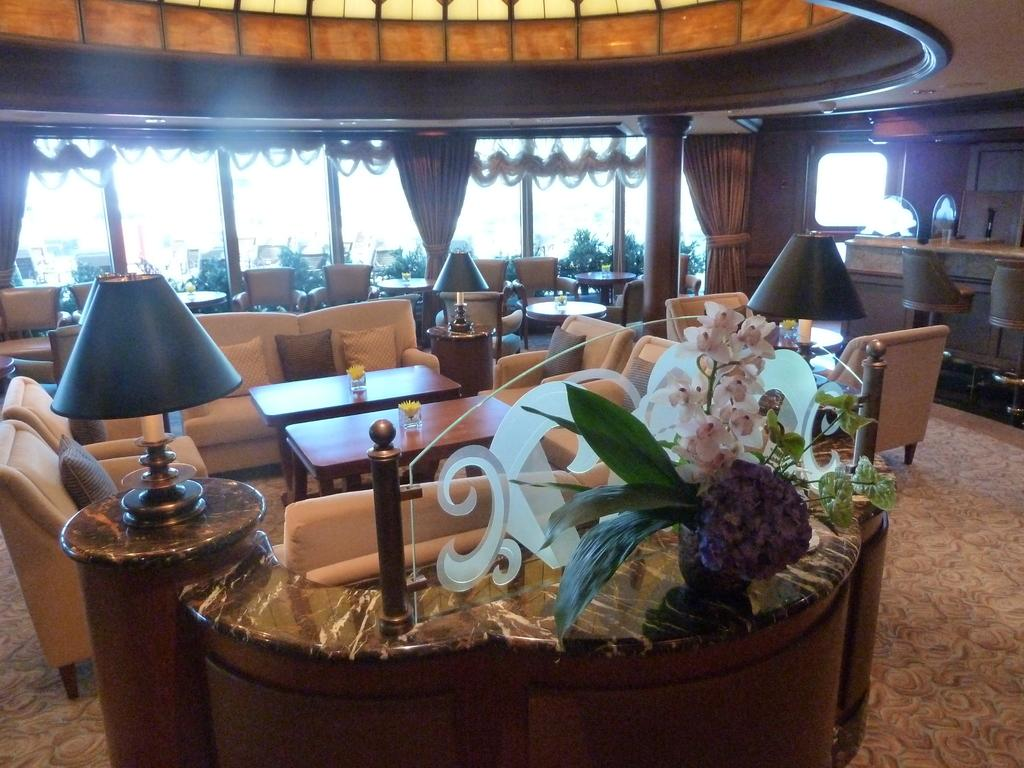What type of furniture is present in the image? There are sofas, tables, and chairs in the image. What type of lighting is present in the image? There are lamps in the image. What type of decorative element is present in the image? There is a plant in the image. What type of window treatment is present in the image? There are curtains in the image. Can you hear your sister whistling in the image? There is no mention of a sister or whistling in the image, so we cannot answer that question. 